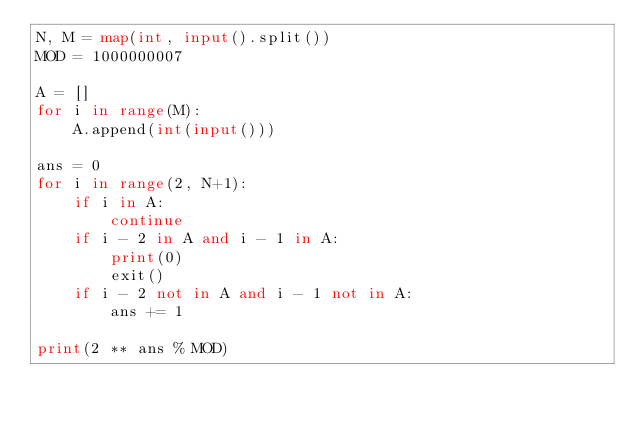<code> <loc_0><loc_0><loc_500><loc_500><_Python_>N, M = map(int, input().split())
MOD = 1000000007

A = []
for i in range(M):
    A.append(int(input()))

ans = 0
for i in range(2, N+1):
    if i in A:
        continue
    if i - 2 in A and i - 1 in A:
        print(0)
        exit()
    if i - 2 not in A and i - 1 not in A:
        ans += 1

print(2 ** ans % MOD)

</code> 